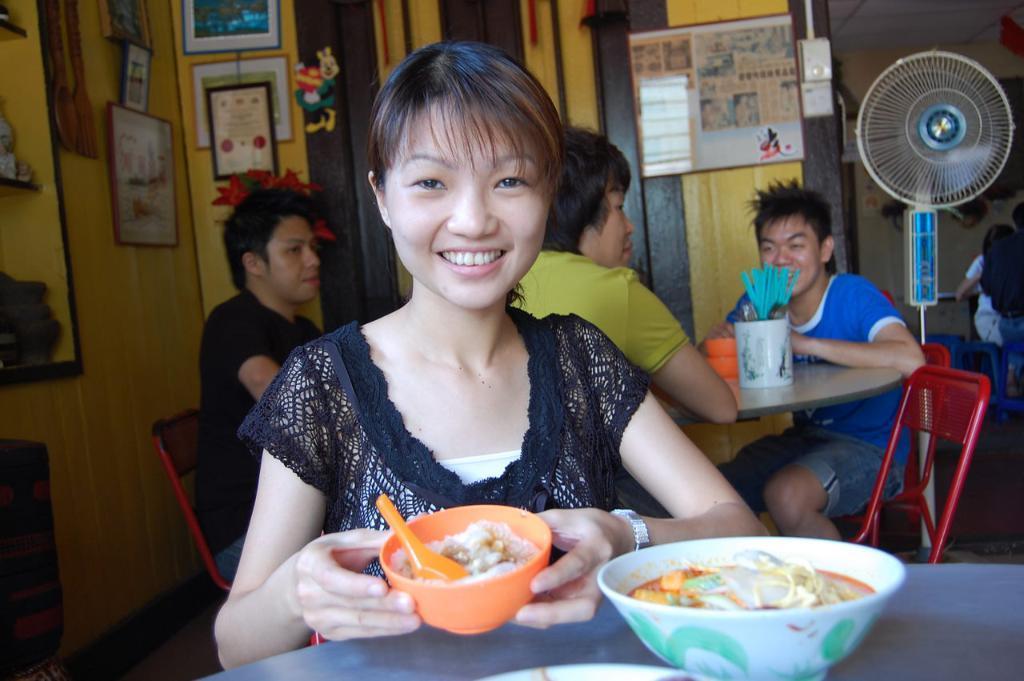In one or two sentences, can you explain what this image depicts? In this image there is one woman sitting and holding a bowl on the bottom of this image and there is one table on the bottom right corner of this image and there is one bowl kept on it. There are some persons sitting on the chairs in the background. there is a wall on top the top of this image, and there are some frames are attached on it, and there is a fan on the right side of this image. There are some objects kept on a table on the right side of this image, and there is one object on the left side of this image. 